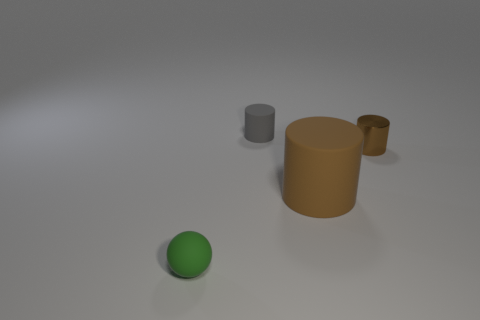Is there anything else that has the same size as the brown matte object?
Provide a succinct answer. No. Is there anything else that is the same shape as the green rubber thing?
Keep it short and to the point. No. What material is the tiny thing in front of the brown cylinder on the left side of the brown object that is behind the big matte thing made of?
Your response must be concise. Rubber. What number of other things are the same material as the large brown object?
Provide a succinct answer. 2. What number of tiny things are in front of the tiny thing behind the brown metallic cylinder?
Make the answer very short. 2. What number of balls are rubber things or tiny brown objects?
Your answer should be very brief. 1. There is a small thing that is in front of the small gray object and to the right of the green rubber thing; what is its color?
Offer a very short reply. Brown. Is there anything else that has the same color as the large cylinder?
Offer a very short reply. Yes. The rubber cylinder in front of the tiny rubber object that is behind the tiny green rubber ball is what color?
Your answer should be very brief. Brown. Is the brown metallic thing the same size as the gray cylinder?
Offer a very short reply. Yes. 